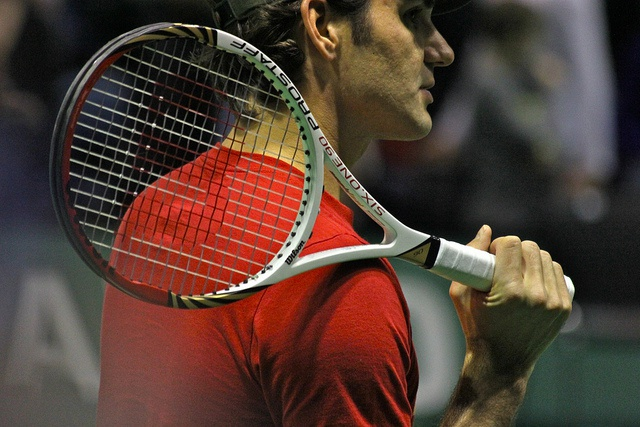Describe the objects in this image and their specific colors. I can see people in brown, black, maroon, and gray tones and tennis racket in gray, black, brown, red, and darkgray tones in this image. 